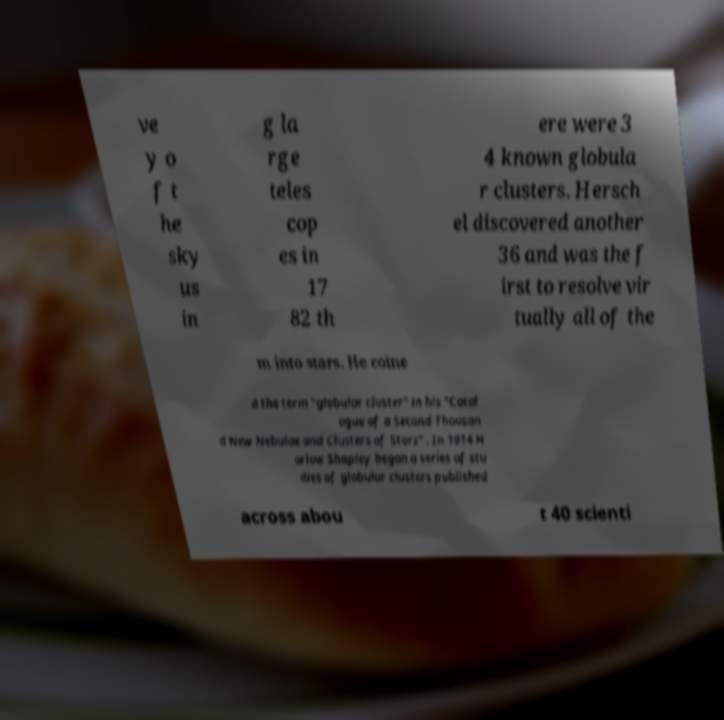For documentation purposes, I need the text within this image transcribed. Could you provide that? ve y o f t he sky us in g la rge teles cop es in 17 82 th ere were 3 4 known globula r clusters. Hersch el discovered another 36 and was the f irst to resolve vir tually all of the m into stars. He coine d the term "globular cluster" in his "Catal ogue of a Second Thousan d New Nebulae and Clusters of Stars" . In 1914 H arlow Shapley began a series of stu dies of globular clusters published across abou t 40 scienti 